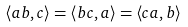<formula> <loc_0><loc_0><loc_500><loc_500>\left < a b , c \right > = \left < b c , a \right > = \left < c a , b \right ></formula> 